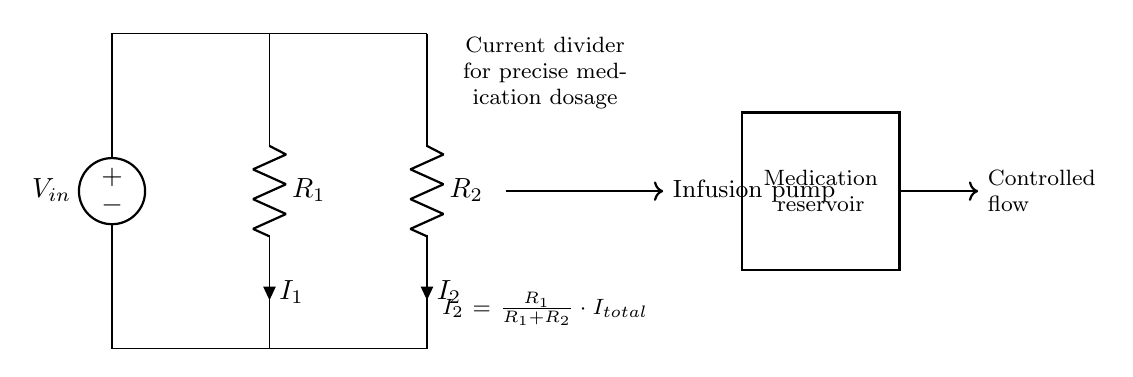What are the resistances in the circuit? The circuit diagram indicates two resistors, labeled R1 and R2, with respective values that are not specified in this diagram. They represent the resistances in the current divider.
Answer: R1 and R2 What is the total current supplied to the circuit? The total current is denoted as I total in the equation displayed in the circuit. It is not specified numerically; it represents the total current flowing into the current divider.
Answer: I total What happens to the total current in this circuit? In a current divider, the total current splits into two branches according to the resistances. The current through each resistor is determined by the resistances R1 and R2, following Ohm's Law.
Answer: It splits into I1 and I2 What is the equation for the current through R2? The equation provided in the diagram states that I2 is equal to the ratio of R1 over the sum of R1 and R2 multiplied by the total current. This reflects the rule for current division in parallel resistors.
Answer: I2 = R1 / (R1 + R2) * I total What does the arrow labeled "Infusion pump" indicate? The arrow signifies the direction of current flow into the infusion pump, which is responsible for controlling the flow of medication. This indicates that the circuit is part of a medical device designed for precise dosages.
Answer: Controlled flow How does the current divider assist in medication dosage? The current divider allows for precise control of the flow rate of medication by varying the resistances R1 and R2, thus enabling tailored dosages based on patient needs. This is crucial for administering accurate drug amounts.
Answer: It provides precise medication control 